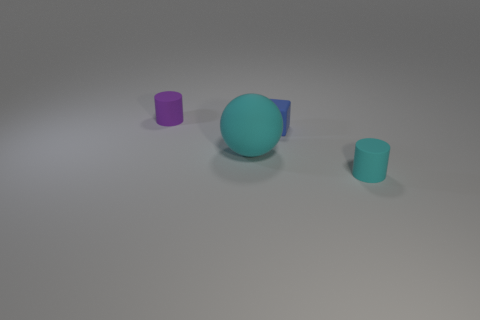Could you describe the color gradient on the objects? Sure! The objects in the image exhibit a smooth gradient of colors. The largest object in the center has a solid teal color, while the small cylindrical objects on the sides transition from teal to a lighter, almost mint green shade and a deep purple, displaying a subtle play of cool tones. 